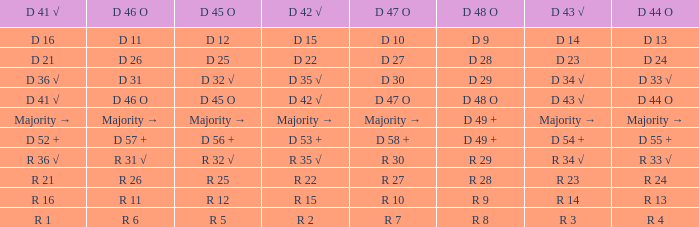Name the D 48 O with D 41 √ of d 41 √ D 48 O. 